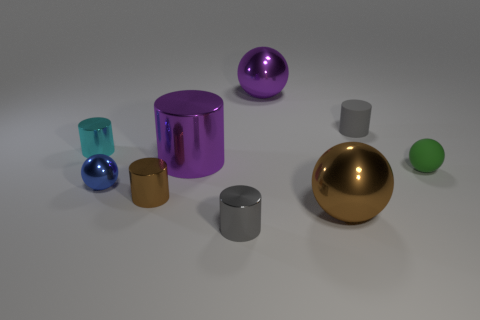Is the number of large purple shiny cylinders that are in front of the large metal cylinder the same as the number of tiny things to the right of the big brown sphere?
Offer a terse response. No. The gray cylinder that is on the left side of the tiny gray object behind the tiny cyan cylinder is made of what material?
Keep it short and to the point. Metal. What number of things are large metal spheres or tiny purple cubes?
Your answer should be compact. 2. What size is the ball that is the same color as the large cylinder?
Offer a terse response. Large. Is the number of brown metallic things less than the number of metallic balls?
Ensure brevity in your answer.  Yes. What is the size of the purple cylinder that is the same material as the tiny brown object?
Ensure brevity in your answer.  Large. How big is the purple cylinder?
Offer a very short reply. Large. There is a tiny gray metallic thing; what shape is it?
Provide a succinct answer. Cylinder. Do the big sphere that is behind the blue thing and the large cylinder have the same color?
Keep it short and to the point. Yes. The green matte object that is the same shape as the blue object is what size?
Ensure brevity in your answer.  Small. 